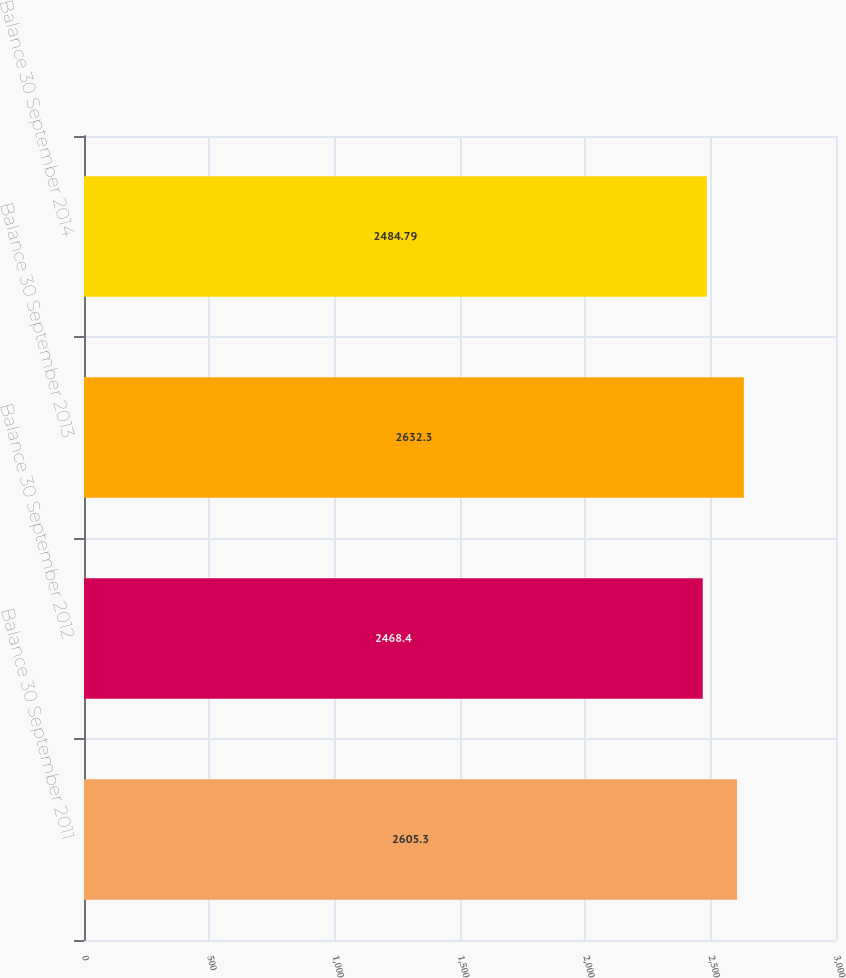Convert chart. <chart><loc_0><loc_0><loc_500><loc_500><bar_chart><fcel>Balance 30 September 2011<fcel>Balance 30 September 2012<fcel>Balance 30 September 2013<fcel>Balance 30 September 2014<nl><fcel>2605.3<fcel>2468.4<fcel>2632.3<fcel>2484.79<nl></chart> 